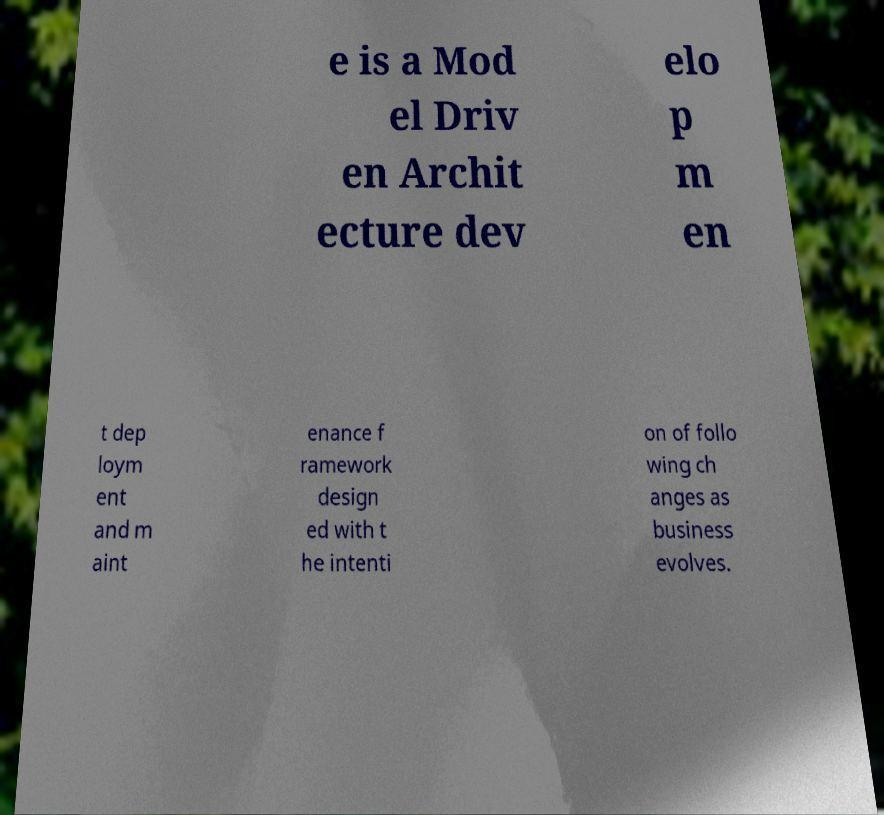There's text embedded in this image that I need extracted. Can you transcribe it verbatim? e is a Mod el Driv en Archit ecture dev elo p m en t dep loym ent and m aint enance f ramework design ed with t he intenti on of follo wing ch anges as business evolves. 